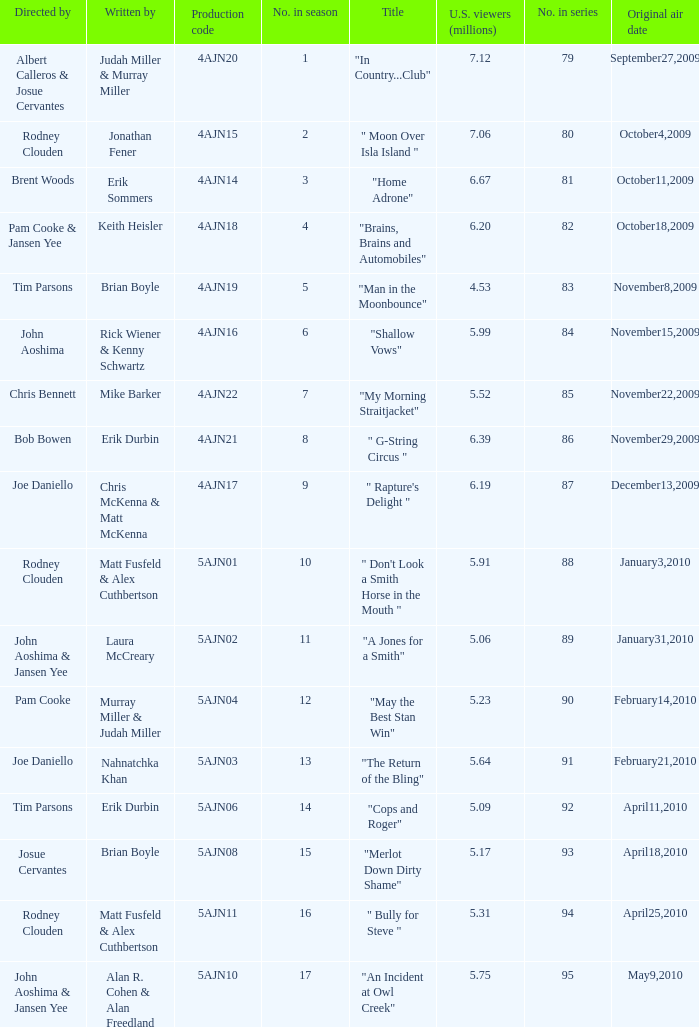Name the original air date for " don't look a smith horse in the mouth " January3,2010. 